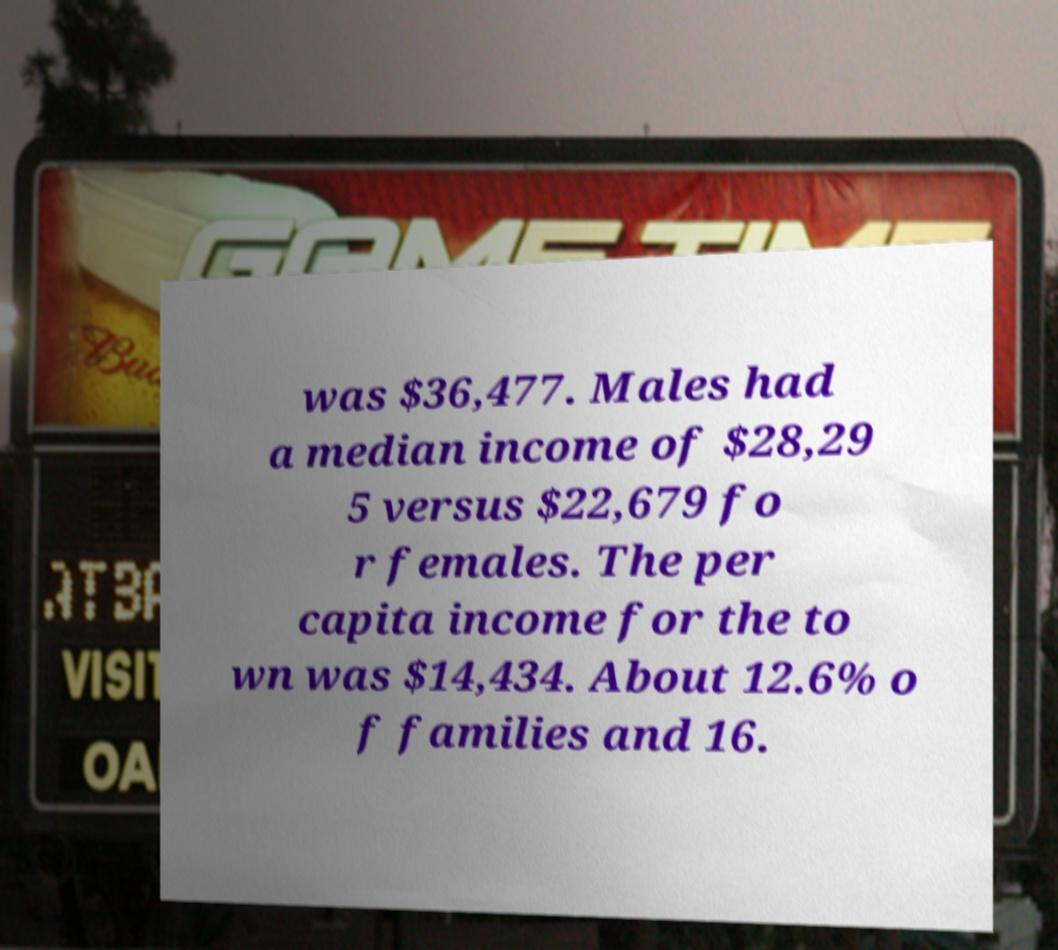Please identify and transcribe the text found in this image. was $36,477. Males had a median income of $28,29 5 versus $22,679 fo r females. The per capita income for the to wn was $14,434. About 12.6% o f families and 16. 